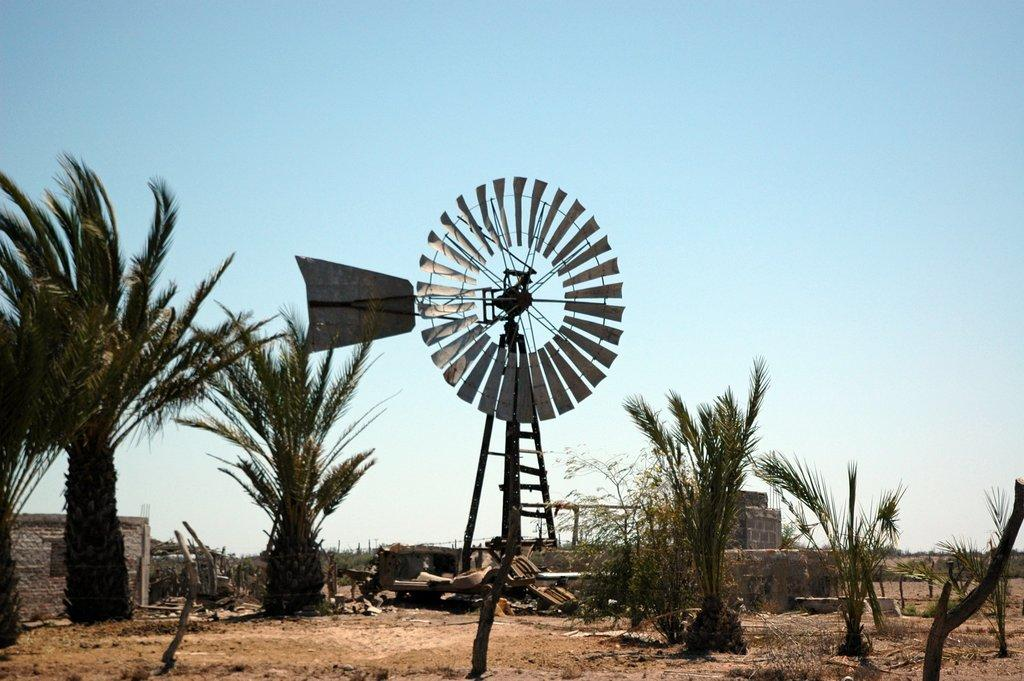What color is the sky in the image? The sky is blue in the image. What type of vegetation can be seen in the image? There are trees in the image. What structure is present in the image? There is a windmill in the image. What year is depicted in the image? The image does not depict a specific year; it is a general scene with a blue sky, trees, and a windmill. What type of work is being done by the windmill in the image? The image does not show the windmill in operation or any specific work being done; it is a static representation of the structure. 